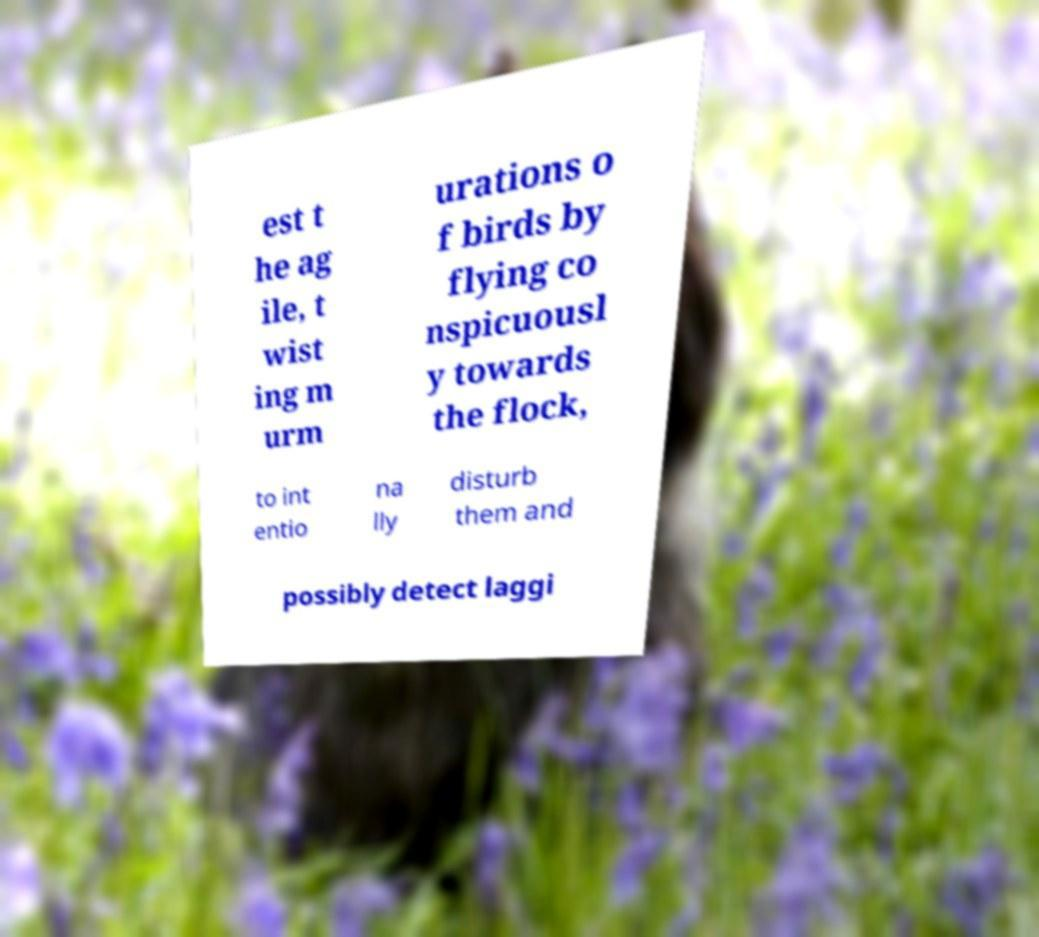Could you extract and type out the text from this image? est t he ag ile, t wist ing m urm urations o f birds by flying co nspicuousl y towards the flock, to int entio na lly disturb them and possibly detect laggi 